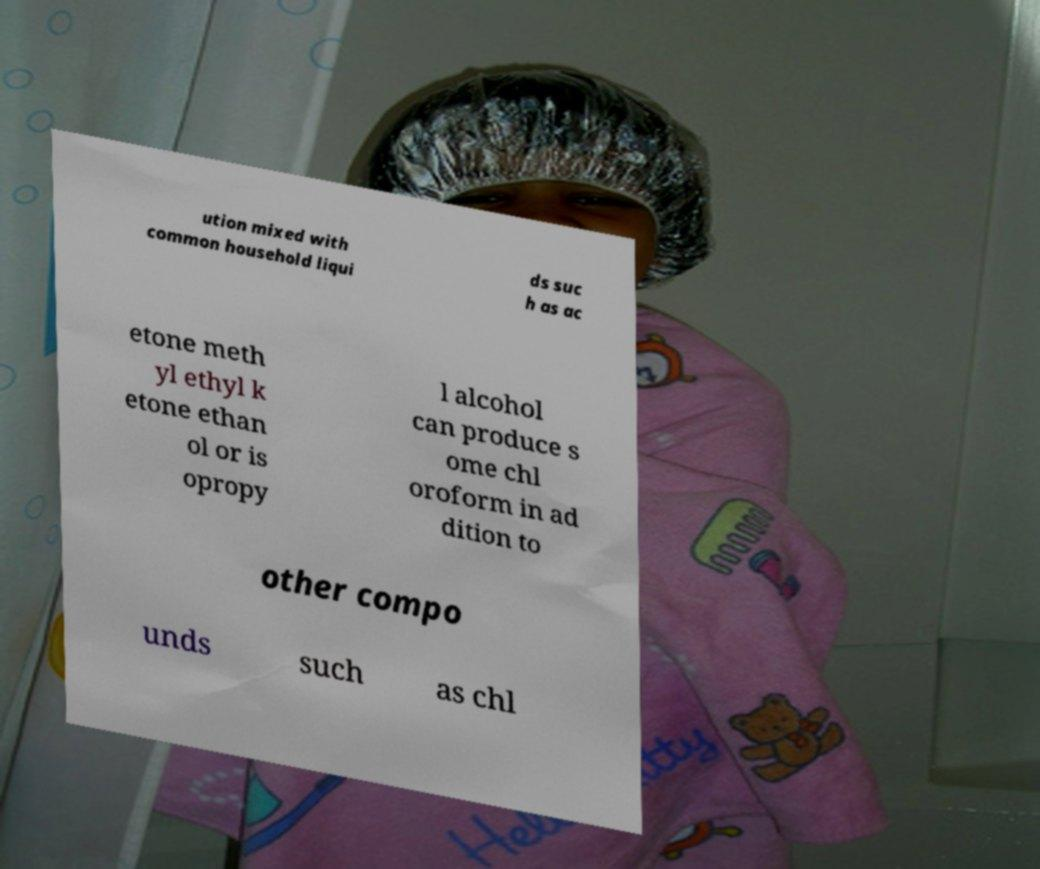Could you extract and type out the text from this image? ution mixed with common household liqui ds suc h as ac etone meth yl ethyl k etone ethan ol or is opropy l alcohol can produce s ome chl oroform in ad dition to other compo unds such as chl 